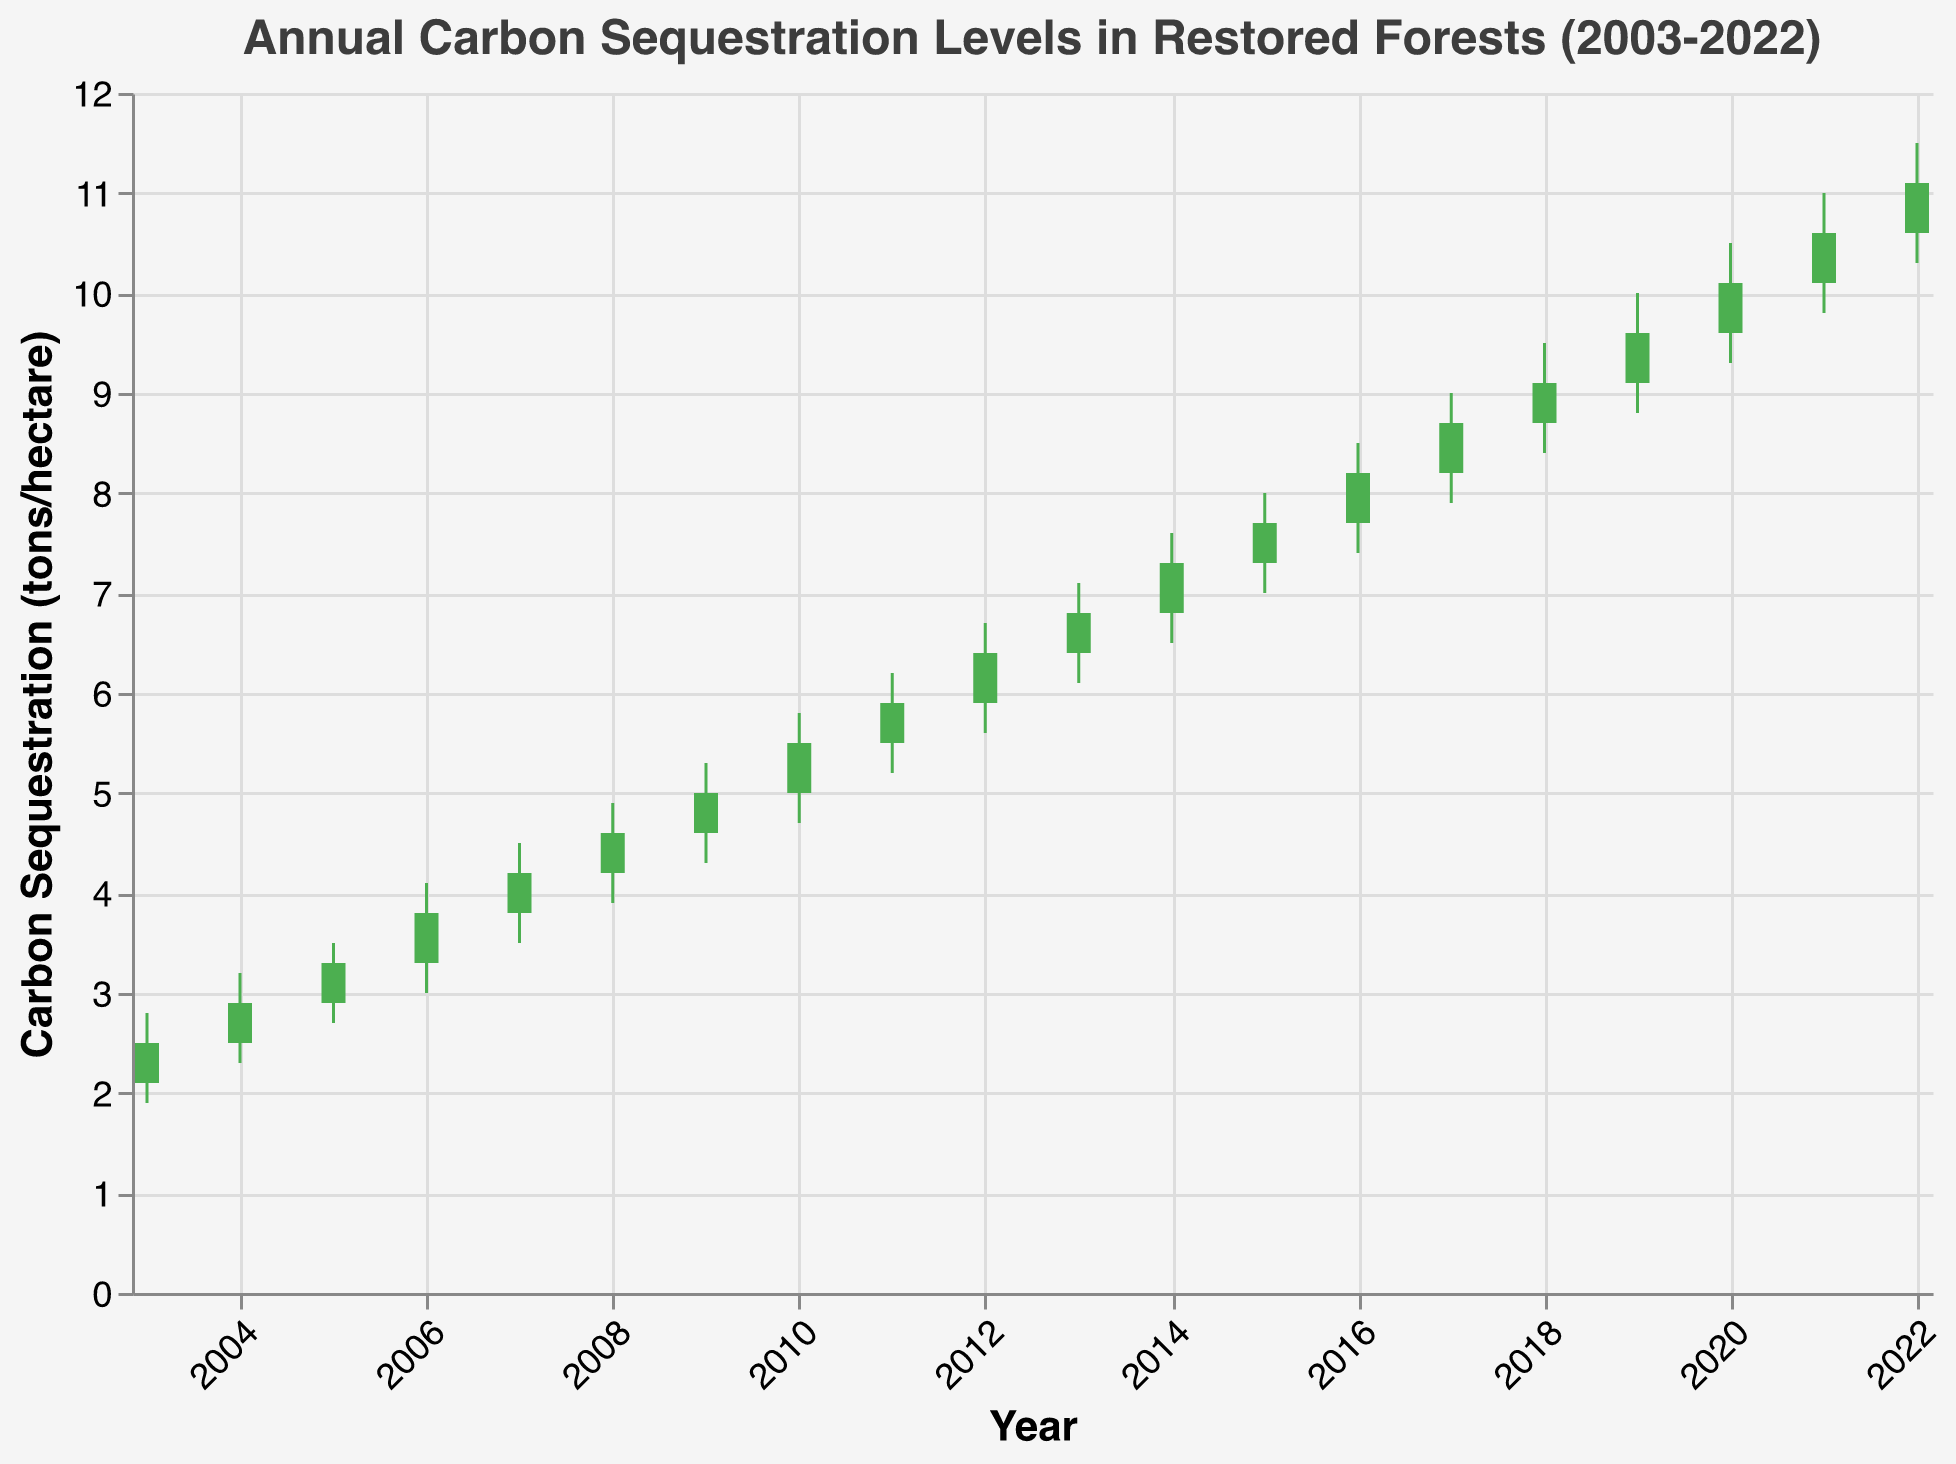What is the title of the chart? The title is located at the top of the chart and provides context for the data being displayed. It reads: "Annual Carbon Sequestration Levels in Restored Forests (2003-2022)."
Answer: Annual Carbon Sequestration Levels in Restored Forests (2003-2022) How many years does the data cover? The x-axis represents the years from 2003 to 2022, a total of 20 years.
Answer: 20 years What is the highest value for carbon sequestration recorded in a single year, and in which year did it occur? By examining the 'High' values on the chart, the highest value is 11.5 tons/hectare in 2022.
Answer: 11.5 tons/hectare in 2022 How much did the carbon sequestration level increase from 2003 to 2022? In 2003, the Close value is 2.5 tons/hectare, and in 2022, the Close value is 11.1 tons/hectare. The increase is calculated as 11.1 - 2.5.
Answer: 8.6 tons/hectare Which years show a decrease in carbon sequestration levels compared to the previous year? By comparing the Close values to the Open values for consecutive years, carbon sequestration decreased from 2011 to 2012 and from 2021 to 2022.
Answer: 2012 and 2022 What is the average Close value for the decade 2011-2020? Extract Close values for 2011 to 2020 (5.9, 6.4, 6.8, 7.3, 7.7, 8.2, 8.7, 9.1, 9.6, 10.1), sum them (79.8), and then divide by 10.
Answer: 7.98 tons/hectare Which year had the largest range in carbon sequestration levels, and what was the range? The range is the difference between the High and Low values. The largest range is in 2021, which is 11.0 - 9.8 = 1.2 tons/hectare.
Answer: 2021, 1.2 tons/hectare Is there any year where the Open value is equal to the Close value? By checking the Open and Close values for each year, there is no year where they are equal.
Answer: No What year had the smallest increase in carbon sequestration levels between the Open and Close values? Compare the difference between Open and Close for each year. The smallest increase is 2004, where the increase is 2.9 - 2.5 = 0.4 tons/hectare.
Answer: 2004 How many years show an increase in carbon sequestration levels? Count the years where Close is greater than Open. According to the data, 18 years show an increase (excluding 2012 and 2022).
Answer: 18 years 